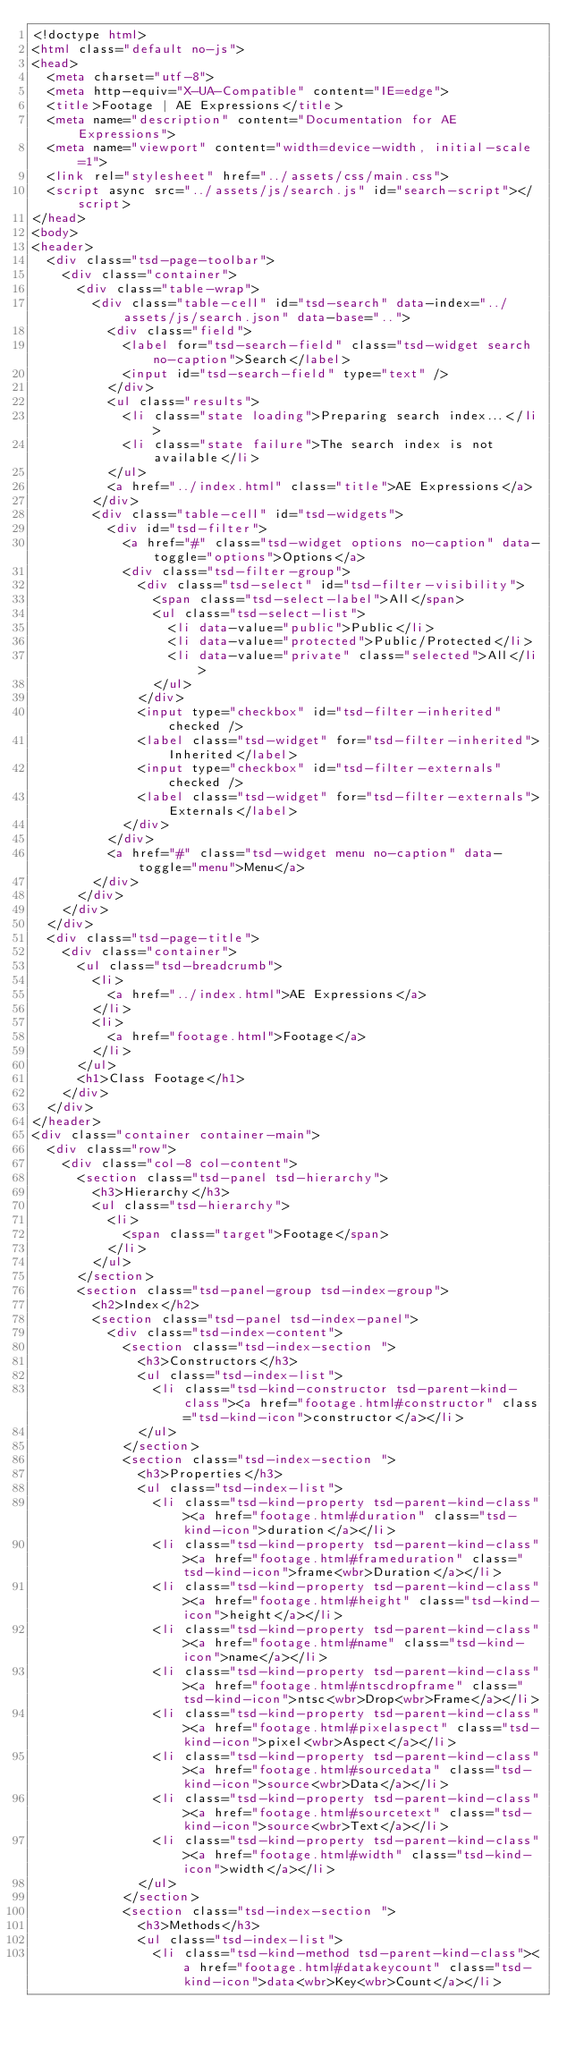Convert code to text. <code><loc_0><loc_0><loc_500><loc_500><_HTML_><!doctype html>
<html class="default no-js">
<head>
	<meta charset="utf-8">
	<meta http-equiv="X-UA-Compatible" content="IE=edge">
	<title>Footage | AE Expressions</title>
	<meta name="description" content="Documentation for AE Expressions">
	<meta name="viewport" content="width=device-width, initial-scale=1">
	<link rel="stylesheet" href="../assets/css/main.css">
	<script async src="../assets/js/search.js" id="search-script"></script>
</head>
<body>
<header>
	<div class="tsd-page-toolbar">
		<div class="container">
			<div class="table-wrap">
				<div class="table-cell" id="tsd-search" data-index="../assets/js/search.json" data-base="..">
					<div class="field">
						<label for="tsd-search-field" class="tsd-widget search no-caption">Search</label>
						<input id="tsd-search-field" type="text" />
					</div>
					<ul class="results">
						<li class="state loading">Preparing search index...</li>
						<li class="state failure">The search index is not available</li>
					</ul>
					<a href="../index.html" class="title">AE Expressions</a>
				</div>
				<div class="table-cell" id="tsd-widgets">
					<div id="tsd-filter">
						<a href="#" class="tsd-widget options no-caption" data-toggle="options">Options</a>
						<div class="tsd-filter-group">
							<div class="tsd-select" id="tsd-filter-visibility">
								<span class="tsd-select-label">All</span>
								<ul class="tsd-select-list">
									<li data-value="public">Public</li>
									<li data-value="protected">Public/Protected</li>
									<li data-value="private" class="selected">All</li>
								</ul>
							</div>
							<input type="checkbox" id="tsd-filter-inherited" checked />
							<label class="tsd-widget" for="tsd-filter-inherited">Inherited</label>
							<input type="checkbox" id="tsd-filter-externals" checked />
							<label class="tsd-widget" for="tsd-filter-externals">Externals</label>
						</div>
					</div>
					<a href="#" class="tsd-widget menu no-caption" data-toggle="menu">Menu</a>
				</div>
			</div>
		</div>
	</div>
	<div class="tsd-page-title">
		<div class="container">
			<ul class="tsd-breadcrumb">
				<li>
					<a href="../index.html">AE Expressions</a>
				</li>
				<li>
					<a href="footage.html">Footage</a>
				</li>
			</ul>
			<h1>Class Footage</h1>
		</div>
	</div>
</header>
<div class="container container-main">
	<div class="row">
		<div class="col-8 col-content">
			<section class="tsd-panel tsd-hierarchy">
				<h3>Hierarchy</h3>
				<ul class="tsd-hierarchy">
					<li>
						<span class="target">Footage</span>
					</li>
				</ul>
			</section>
			<section class="tsd-panel-group tsd-index-group">
				<h2>Index</h2>
				<section class="tsd-panel tsd-index-panel">
					<div class="tsd-index-content">
						<section class="tsd-index-section ">
							<h3>Constructors</h3>
							<ul class="tsd-index-list">
								<li class="tsd-kind-constructor tsd-parent-kind-class"><a href="footage.html#constructor" class="tsd-kind-icon">constructor</a></li>
							</ul>
						</section>
						<section class="tsd-index-section ">
							<h3>Properties</h3>
							<ul class="tsd-index-list">
								<li class="tsd-kind-property tsd-parent-kind-class"><a href="footage.html#duration" class="tsd-kind-icon">duration</a></li>
								<li class="tsd-kind-property tsd-parent-kind-class"><a href="footage.html#frameduration" class="tsd-kind-icon">frame<wbr>Duration</a></li>
								<li class="tsd-kind-property tsd-parent-kind-class"><a href="footage.html#height" class="tsd-kind-icon">height</a></li>
								<li class="tsd-kind-property tsd-parent-kind-class"><a href="footage.html#name" class="tsd-kind-icon">name</a></li>
								<li class="tsd-kind-property tsd-parent-kind-class"><a href="footage.html#ntscdropframe" class="tsd-kind-icon">ntsc<wbr>Drop<wbr>Frame</a></li>
								<li class="tsd-kind-property tsd-parent-kind-class"><a href="footage.html#pixelaspect" class="tsd-kind-icon">pixel<wbr>Aspect</a></li>
								<li class="tsd-kind-property tsd-parent-kind-class"><a href="footage.html#sourcedata" class="tsd-kind-icon">source<wbr>Data</a></li>
								<li class="tsd-kind-property tsd-parent-kind-class"><a href="footage.html#sourcetext" class="tsd-kind-icon">source<wbr>Text</a></li>
								<li class="tsd-kind-property tsd-parent-kind-class"><a href="footage.html#width" class="tsd-kind-icon">width</a></li>
							</ul>
						</section>
						<section class="tsd-index-section ">
							<h3>Methods</h3>
							<ul class="tsd-index-list">
								<li class="tsd-kind-method tsd-parent-kind-class"><a href="footage.html#datakeycount" class="tsd-kind-icon">data<wbr>Key<wbr>Count</a></li></code> 